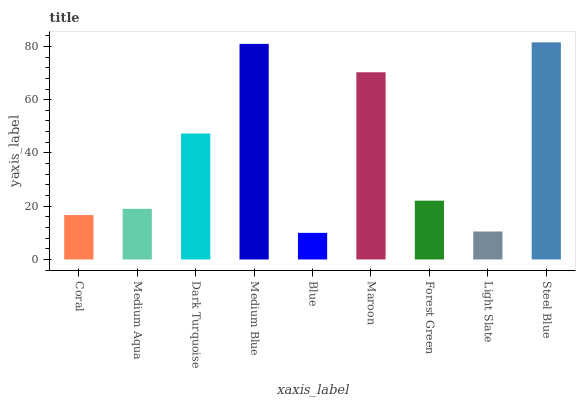Is Blue the minimum?
Answer yes or no. Yes. Is Steel Blue the maximum?
Answer yes or no. Yes. Is Medium Aqua the minimum?
Answer yes or no. No. Is Medium Aqua the maximum?
Answer yes or no. No. Is Medium Aqua greater than Coral?
Answer yes or no. Yes. Is Coral less than Medium Aqua?
Answer yes or no. Yes. Is Coral greater than Medium Aqua?
Answer yes or no. No. Is Medium Aqua less than Coral?
Answer yes or no. No. Is Forest Green the high median?
Answer yes or no. Yes. Is Forest Green the low median?
Answer yes or no. Yes. Is Coral the high median?
Answer yes or no. No. Is Blue the low median?
Answer yes or no. No. 